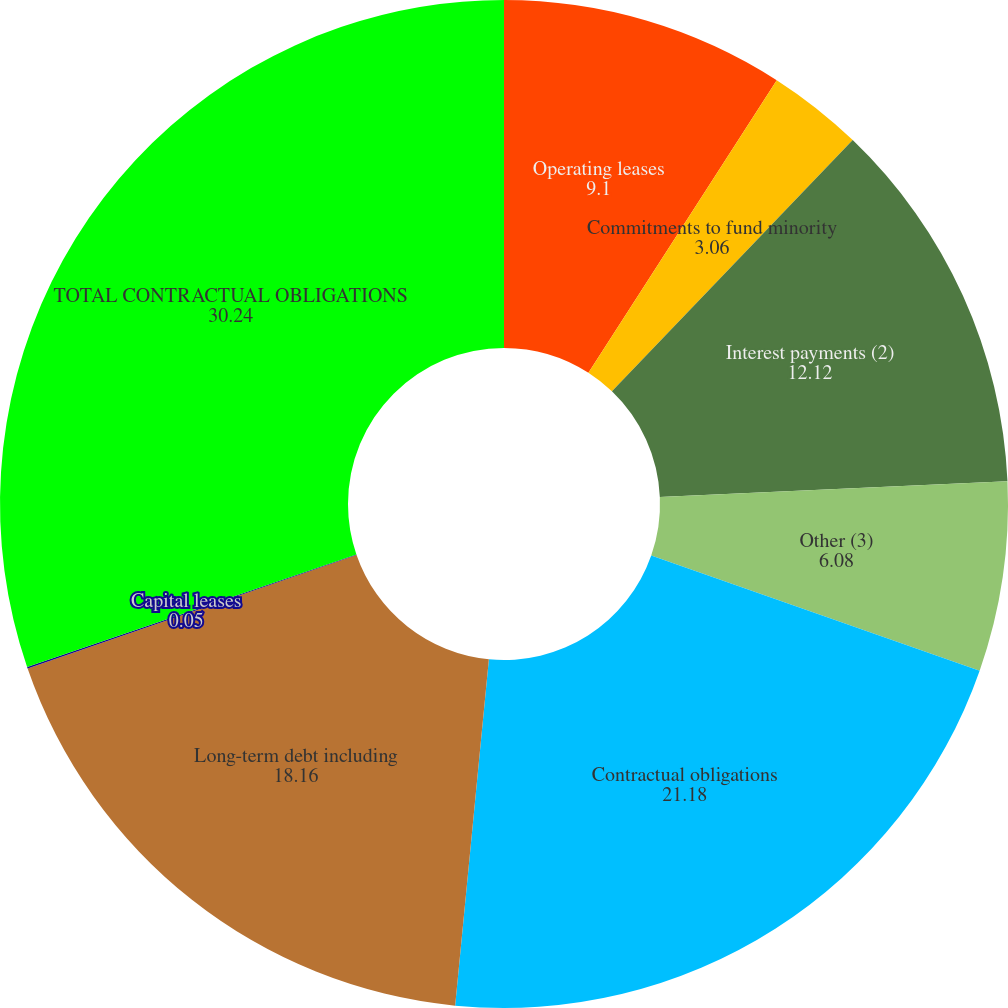Convert chart. <chart><loc_0><loc_0><loc_500><loc_500><pie_chart><fcel>Operating leases<fcel>Commitments to fund minority<fcel>Interest payments (2)<fcel>Other (3)<fcel>Contractual obligations<fcel>Long-term debt including<fcel>Capital leases<fcel>TOTAL CONTRACTUAL OBLIGATIONS<nl><fcel>9.1%<fcel>3.06%<fcel>12.12%<fcel>6.08%<fcel>21.18%<fcel>18.16%<fcel>0.05%<fcel>30.24%<nl></chart> 